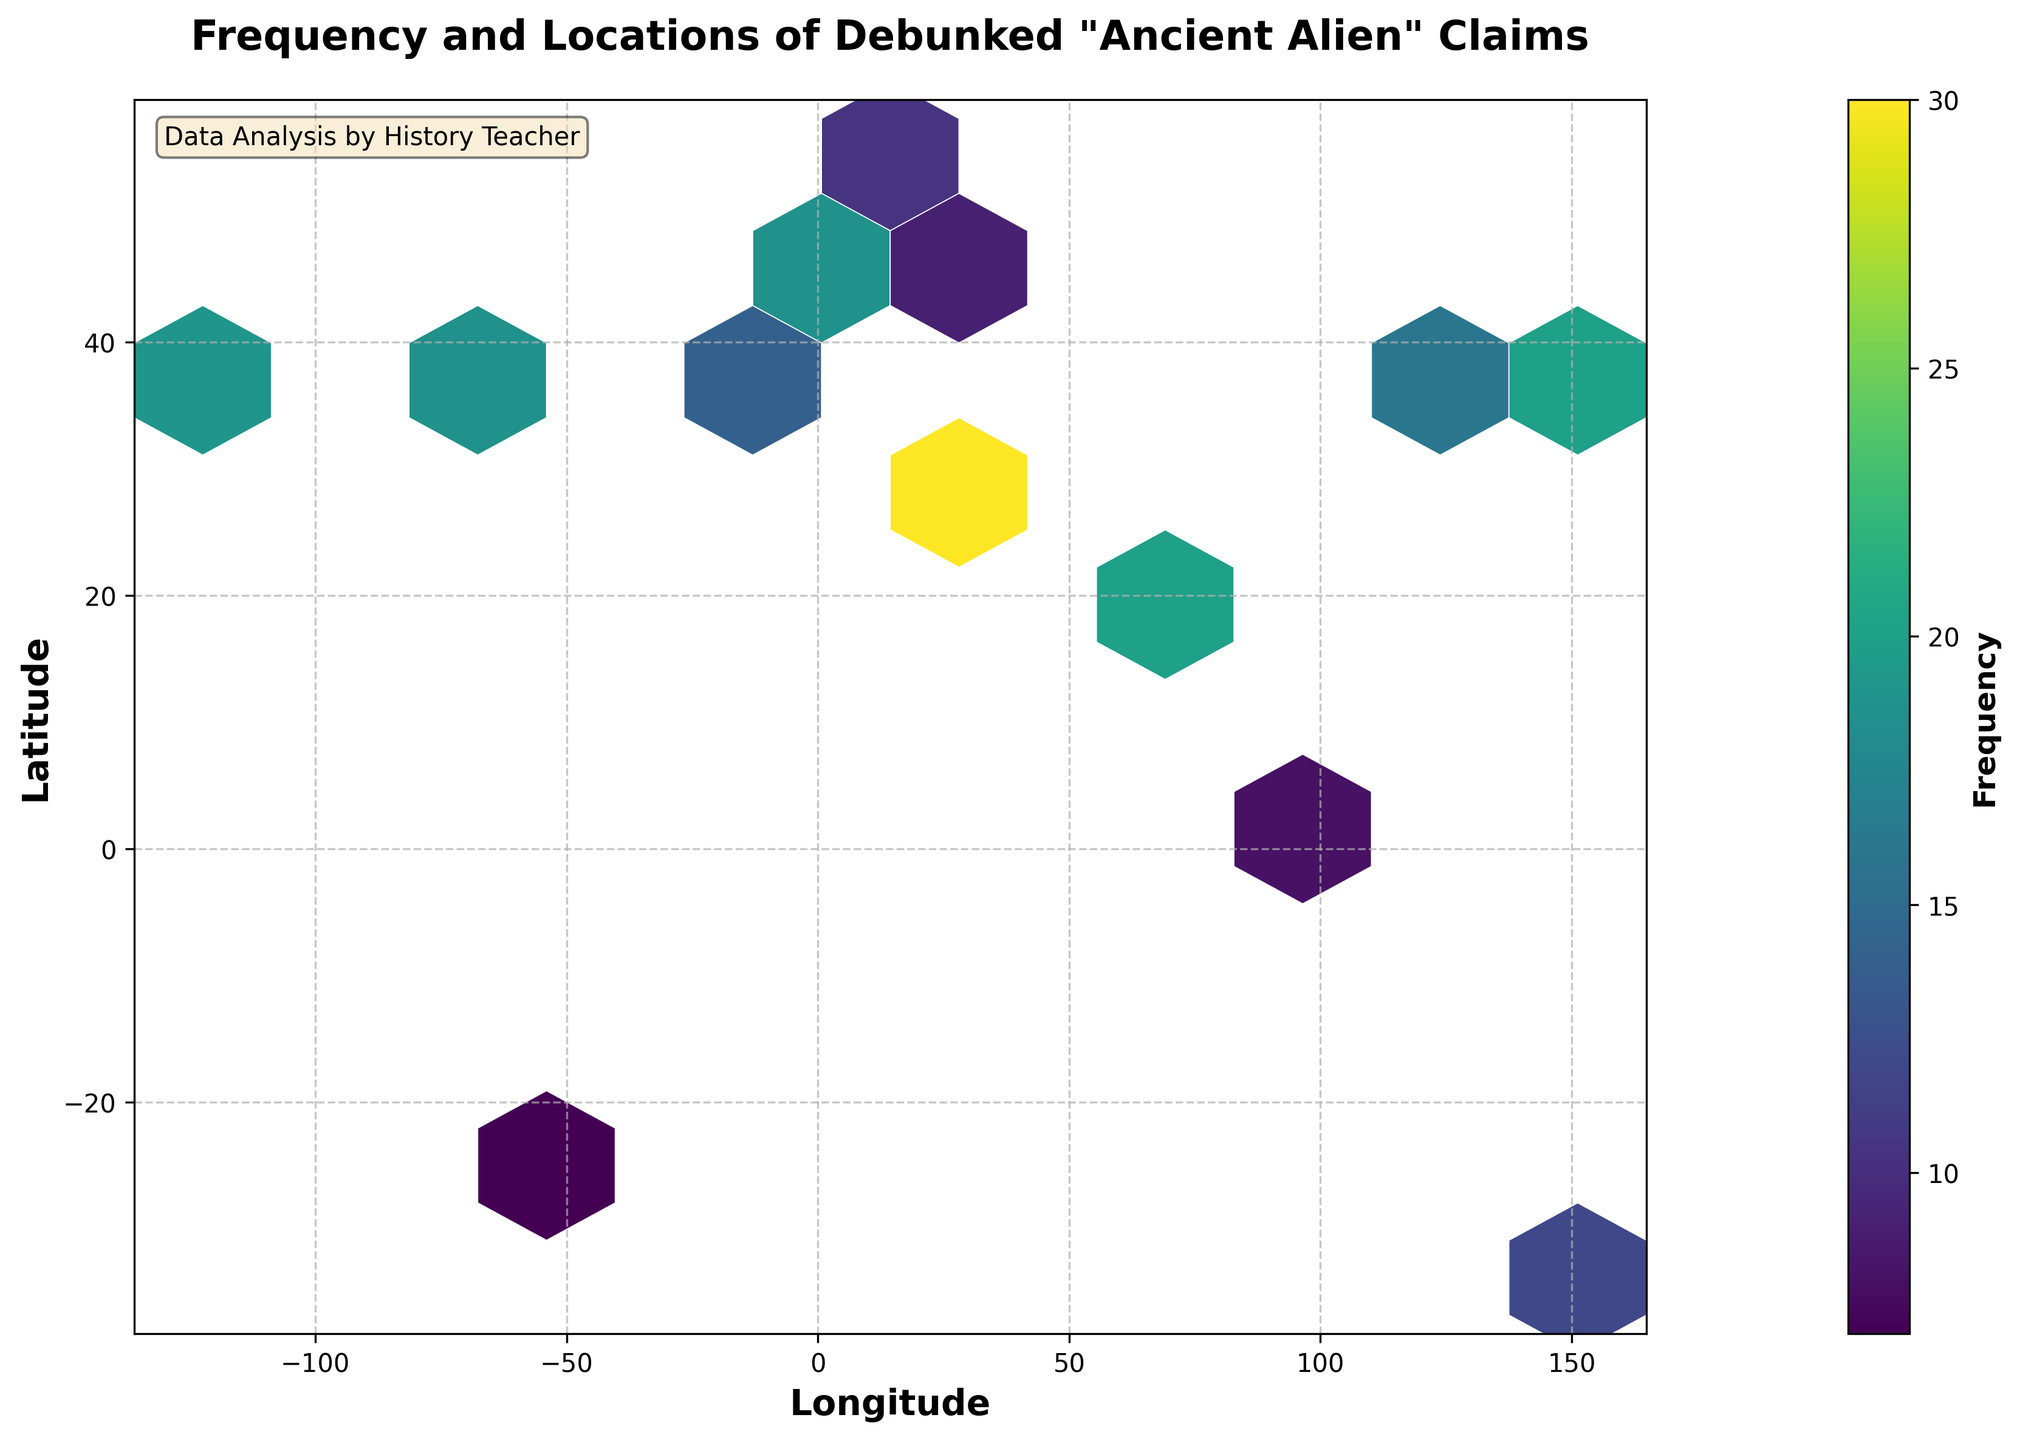What's the title of the figure? The title is typically at the top of the figure and is clearly visible. It summarizes what the figure is about.
Answer: Frequency and Locations of Debunked "Ancient Alien" Claims What do the axes represent? The x-axis and y-axis labels usually describe what each axis measures. In this case, they are labeled for geographical coordinates.
Answer: Longitude and Latitude Which location has the highest frequency of debunked "ancient alien" claims? By looking at the color intensity in the hexbin plot, one can identify the hexbin with the highest frequency value. The color bar indicates that higher frequencies are shown in lighter colors.
Answer: 35.2137, 31.7683 Are there more debunked claims in the Northern Hemisphere or the Southern Hemisphere? The Northern Hemisphere includes latitudes greater than 0, whereas the Southern Hemisphere includes latitudes less than 0. Observing the density of hexagons in each hemisphere will provide the answer.
Answer: Northern Hemisphere What are some of the locations with a frequency of debunked claims between 10 and 20? By checking the colors corresponding to frequencies between 10 and 20 on the color bar, we can identify these locations.
Answer: UAE (25.2867, 54.6872), Germany (13.4050, 52.5200), Spain (-3.7038, 40.4168), Japan (139.6917, 35.6895), India (72.8777, 19.0760) Is there any location with a frequency just below 10? Frequencies just below 10 would be indicated by colors slightly darker than those for a frequency of 10.
Answer: Turkey (28.9784, 41.0082), Brazil (-43.1729, -22.9068), Singapore (103.8198, 1.3521) How does the frequency of debunked claims in London compare to that in Paris? Compare the frequency values for London (51.5074N, -0.1276W) and Paris (48.8566N, 2.3522E). The color coding will help determine which is higher.
Answer: Paris has a higher frequency What's the average frequency of debunked claims for the cities with latitude above 40? First, identify the cities with a latitude above 40. Then, sum their frequencies and divide by the number of such cities.
Answer: (15+22+18+28+9+13+14+11)/8 = 16.25 Which city in the data has the lowest frequency of debunked claims? Find the city corresponding to the darkest color hexbin or the smallest frequency value in the data.
Answer: Rio de Janeiro (-43.1729, -22.9068) What's the geographic range covered by the figure? The range is given by the span of the x-axis (longitude) and the y-axis (latitude). The maxima and minima on these axes provide this information.
Answer: Longitude: -122.4194 to 151.2093, Latitude: -33.8688 to 52.5200 